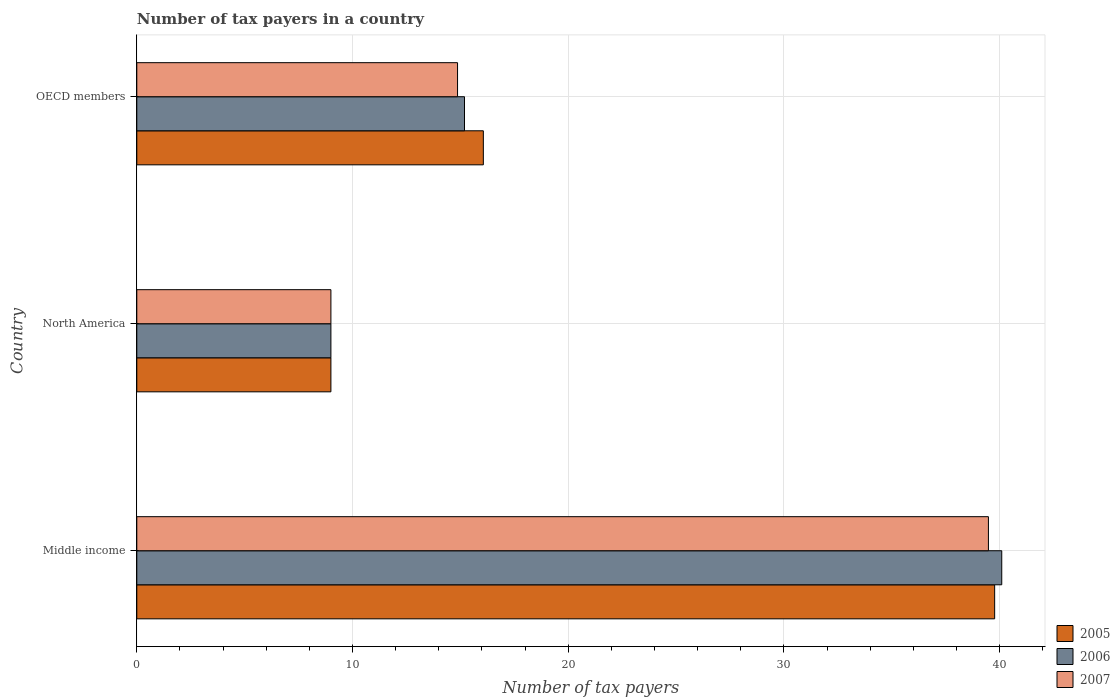How many groups of bars are there?
Provide a succinct answer. 3. Are the number of bars on each tick of the Y-axis equal?
Your response must be concise. Yes. How many bars are there on the 3rd tick from the top?
Your response must be concise. 3. How many bars are there on the 3rd tick from the bottom?
Make the answer very short. 3. In how many cases, is the number of bars for a given country not equal to the number of legend labels?
Offer a very short reply. 0. Across all countries, what is the maximum number of tax payers in in 2006?
Keep it short and to the point. 40.1. In which country was the number of tax payers in in 2006 maximum?
Keep it short and to the point. Middle income. What is the total number of tax payers in in 2007 in the graph?
Keep it short and to the point. 63.35. What is the difference between the number of tax payers in in 2006 in Middle income and that in North America?
Your response must be concise. 31.1. What is the difference between the number of tax payers in in 2006 in Middle income and the number of tax payers in in 2007 in North America?
Provide a short and direct response. 31.1. What is the average number of tax payers in in 2007 per country?
Your answer should be compact. 21.12. What is the ratio of the number of tax payers in in 2005 in Middle income to that in North America?
Make the answer very short. 4.42. Is the number of tax payers in in 2005 in North America less than that in OECD members?
Ensure brevity in your answer.  Yes. What is the difference between the highest and the second highest number of tax payers in in 2007?
Offer a very short reply. 24.61. What is the difference between the highest and the lowest number of tax payers in in 2005?
Keep it short and to the point. 30.77. In how many countries, is the number of tax payers in in 2007 greater than the average number of tax payers in in 2007 taken over all countries?
Your response must be concise. 1. Is the sum of the number of tax payers in in 2007 in Middle income and North America greater than the maximum number of tax payers in in 2006 across all countries?
Give a very brief answer. Yes. What does the 1st bar from the top in Middle income represents?
Offer a terse response. 2007. What does the 1st bar from the bottom in Middle income represents?
Give a very brief answer. 2005. How many countries are there in the graph?
Your response must be concise. 3. Are the values on the major ticks of X-axis written in scientific E-notation?
Give a very brief answer. No. Does the graph contain grids?
Ensure brevity in your answer.  Yes. How many legend labels are there?
Provide a short and direct response. 3. How are the legend labels stacked?
Keep it short and to the point. Vertical. What is the title of the graph?
Your response must be concise. Number of tax payers in a country. What is the label or title of the X-axis?
Keep it short and to the point. Number of tax payers. What is the label or title of the Y-axis?
Make the answer very short. Country. What is the Number of tax payers of 2005 in Middle income?
Offer a terse response. 39.77. What is the Number of tax payers in 2006 in Middle income?
Ensure brevity in your answer.  40.1. What is the Number of tax payers of 2007 in Middle income?
Ensure brevity in your answer.  39.48. What is the Number of tax payers of 2005 in North America?
Ensure brevity in your answer.  9. What is the Number of tax payers in 2007 in North America?
Offer a very short reply. 9. What is the Number of tax payers of 2005 in OECD members?
Provide a short and direct response. 16.07. What is the Number of tax payers of 2006 in OECD members?
Offer a very short reply. 15.19. What is the Number of tax payers of 2007 in OECD members?
Offer a terse response. 14.87. Across all countries, what is the maximum Number of tax payers of 2005?
Provide a succinct answer. 39.77. Across all countries, what is the maximum Number of tax payers of 2006?
Make the answer very short. 40.1. Across all countries, what is the maximum Number of tax payers in 2007?
Your response must be concise. 39.48. Across all countries, what is the minimum Number of tax payers of 2006?
Keep it short and to the point. 9. Across all countries, what is the minimum Number of tax payers of 2007?
Offer a very short reply. 9. What is the total Number of tax payers of 2005 in the graph?
Your response must be concise. 64.84. What is the total Number of tax payers in 2006 in the graph?
Your answer should be compact. 64.29. What is the total Number of tax payers in 2007 in the graph?
Your answer should be compact. 63.35. What is the difference between the Number of tax payers in 2005 in Middle income and that in North America?
Provide a succinct answer. 30.77. What is the difference between the Number of tax payers of 2006 in Middle income and that in North America?
Your response must be concise. 31.1. What is the difference between the Number of tax payers in 2007 in Middle income and that in North America?
Keep it short and to the point. 30.48. What is the difference between the Number of tax payers of 2005 in Middle income and that in OECD members?
Provide a short and direct response. 23.71. What is the difference between the Number of tax payers in 2006 in Middle income and that in OECD members?
Your answer should be very brief. 24.91. What is the difference between the Number of tax payers in 2007 in Middle income and that in OECD members?
Make the answer very short. 24.61. What is the difference between the Number of tax payers of 2005 in North America and that in OECD members?
Your response must be concise. -7.07. What is the difference between the Number of tax payers of 2006 in North America and that in OECD members?
Keep it short and to the point. -6.19. What is the difference between the Number of tax payers in 2007 in North America and that in OECD members?
Ensure brevity in your answer.  -5.87. What is the difference between the Number of tax payers in 2005 in Middle income and the Number of tax payers in 2006 in North America?
Make the answer very short. 30.77. What is the difference between the Number of tax payers in 2005 in Middle income and the Number of tax payers in 2007 in North America?
Provide a short and direct response. 30.77. What is the difference between the Number of tax payers of 2006 in Middle income and the Number of tax payers of 2007 in North America?
Keep it short and to the point. 31.1. What is the difference between the Number of tax payers in 2005 in Middle income and the Number of tax payers in 2006 in OECD members?
Offer a very short reply. 24.58. What is the difference between the Number of tax payers of 2005 in Middle income and the Number of tax payers of 2007 in OECD members?
Ensure brevity in your answer.  24.9. What is the difference between the Number of tax payers in 2006 in Middle income and the Number of tax payers in 2007 in OECD members?
Provide a succinct answer. 25.23. What is the difference between the Number of tax payers of 2005 in North America and the Number of tax payers of 2006 in OECD members?
Your response must be concise. -6.19. What is the difference between the Number of tax payers in 2005 in North America and the Number of tax payers in 2007 in OECD members?
Keep it short and to the point. -5.87. What is the difference between the Number of tax payers in 2006 in North America and the Number of tax payers in 2007 in OECD members?
Provide a succinct answer. -5.87. What is the average Number of tax payers in 2005 per country?
Keep it short and to the point. 21.61. What is the average Number of tax payers in 2006 per country?
Your answer should be very brief. 21.43. What is the average Number of tax payers in 2007 per country?
Your answer should be compact. 21.12. What is the difference between the Number of tax payers of 2005 and Number of tax payers of 2006 in Middle income?
Your answer should be compact. -0.33. What is the difference between the Number of tax payers of 2005 and Number of tax payers of 2007 in Middle income?
Make the answer very short. 0.29. What is the difference between the Number of tax payers of 2006 and Number of tax payers of 2007 in Middle income?
Offer a terse response. 0.62. What is the difference between the Number of tax payers of 2005 and Number of tax payers of 2006 in OECD members?
Offer a terse response. 0.87. What is the difference between the Number of tax payers of 2005 and Number of tax payers of 2007 in OECD members?
Your answer should be compact. 1.2. What is the difference between the Number of tax payers in 2006 and Number of tax payers in 2007 in OECD members?
Your answer should be compact. 0.32. What is the ratio of the Number of tax payers of 2005 in Middle income to that in North America?
Make the answer very short. 4.42. What is the ratio of the Number of tax payers in 2006 in Middle income to that in North America?
Ensure brevity in your answer.  4.46. What is the ratio of the Number of tax payers in 2007 in Middle income to that in North America?
Give a very brief answer. 4.39. What is the ratio of the Number of tax payers of 2005 in Middle income to that in OECD members?
Ensure brevity in your answer.  2.48. What is the ratio of the Number of tax payers of 2006 in Middle income to that in OECD members?
Your answer should be compact. 2.64. What is the ratio of the Number of tax payers in 2007 in Middle income to that in OECD members?
Ensure brevity in your answer.  2.65. What is the ratio of the Number of tax payers of 2005 in North America to that in OECD members?
Keep it short and to the point. 0.56. What is the ratio of the Number of tax payers in 2006 in North America to that in OECD members?
Your answer should be very brief. 0.59. What is the ratio of the Number of tax payers of 2007 in North America to that in OECD members?
Make the answer very short. 0.61. What is the difference between the highest and the second highest Number of tax payers of 2005?
Make the answer very short. 23.71. What is the difference between the highest and the second highest Number of tax payers of 2006?
Your answer should be very brief. 24.91. What is the difference between the highest and the second highest Number of tax payers in 2007?
Offer a terse response. 24.61. What is the difference between the highest and the lowest Number of tax payers in 2005?
Provide a succinct answer. 30.77. What is the difference between the highest and the lowest Number of tax payers in 2006?
Your response must be concise. 31.1. What is the difference between the highest and the lowest Number of tax payers of 2007?
Give a very brief answer. 30.48. 